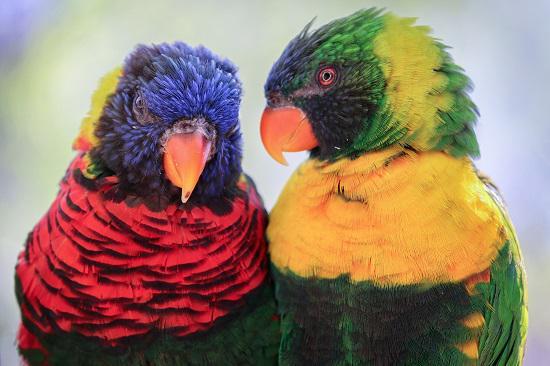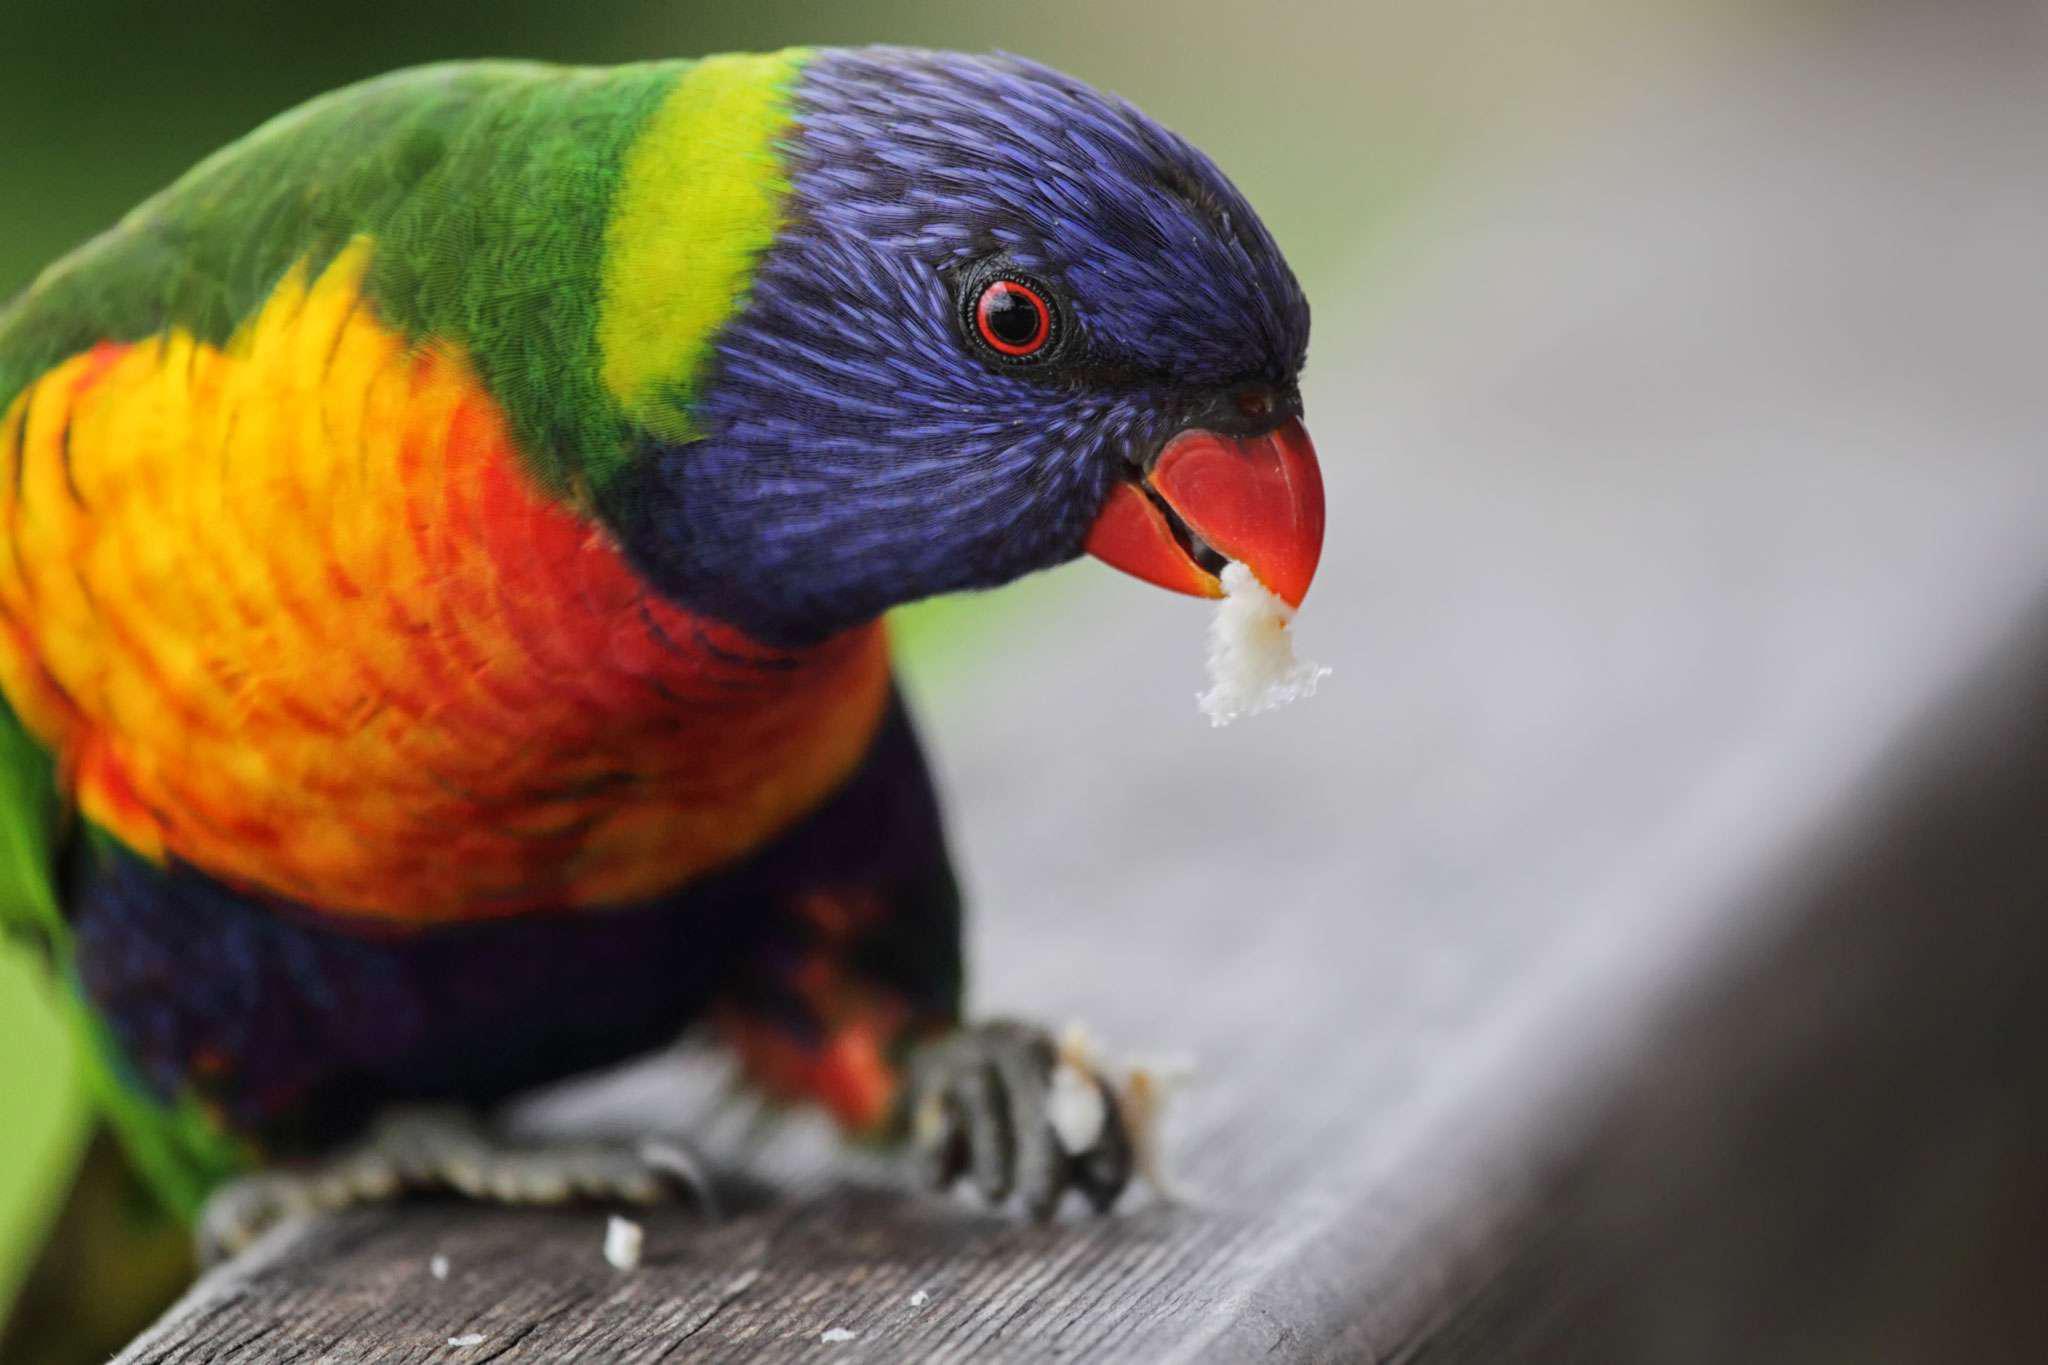The first image is the image on the left, the second image is the image on the right. Analyze the images presented: Is the assertion "In at least one image a single visually perched bird with blue and green feather is facing right." valid? Answer yes or no. Yes. The first image is the image on the left, the second image is the image on the right. Considering the images on both sides, is "Every bird has a head that is more than half blue." valid? Answer yes or no. No. 